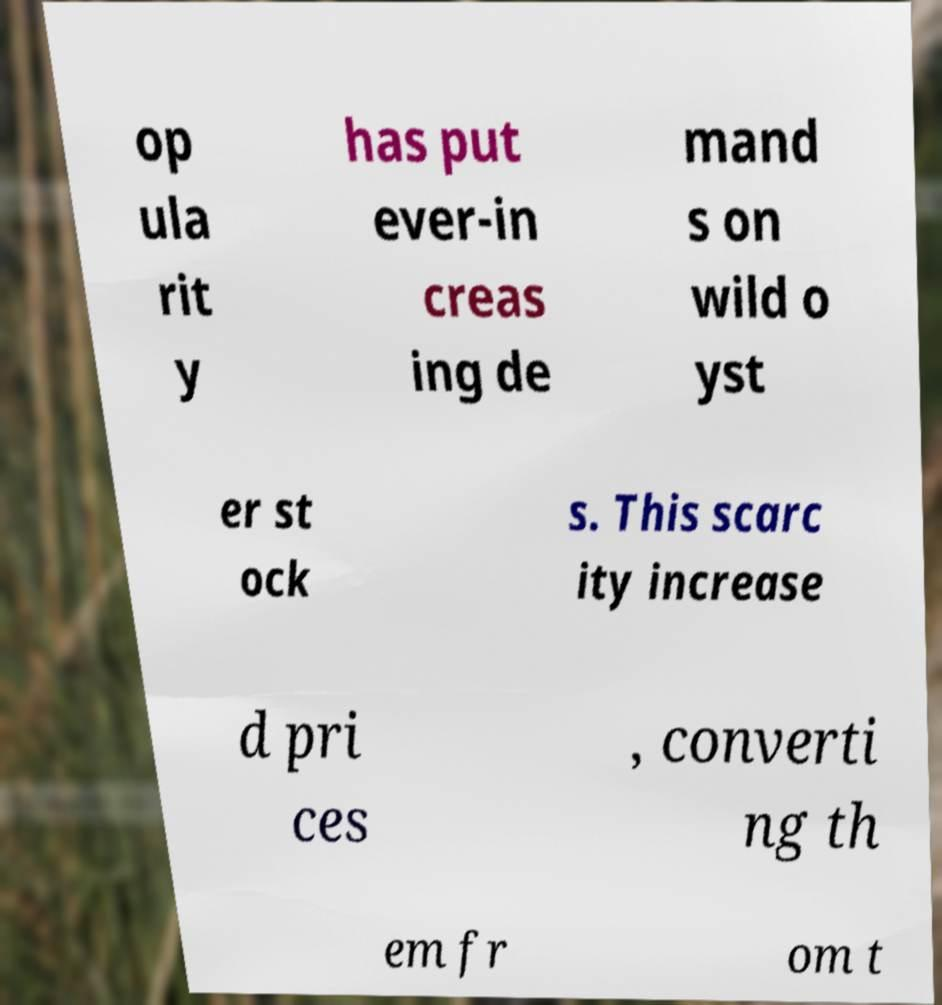Could you assist in decoding the text presented in this image and type it out clearly? op ula rit y has put ever-in creas ing de mand s on wild o yst er st ock s. This scarc ity increase d pri ces , converti ng th em fr om t 